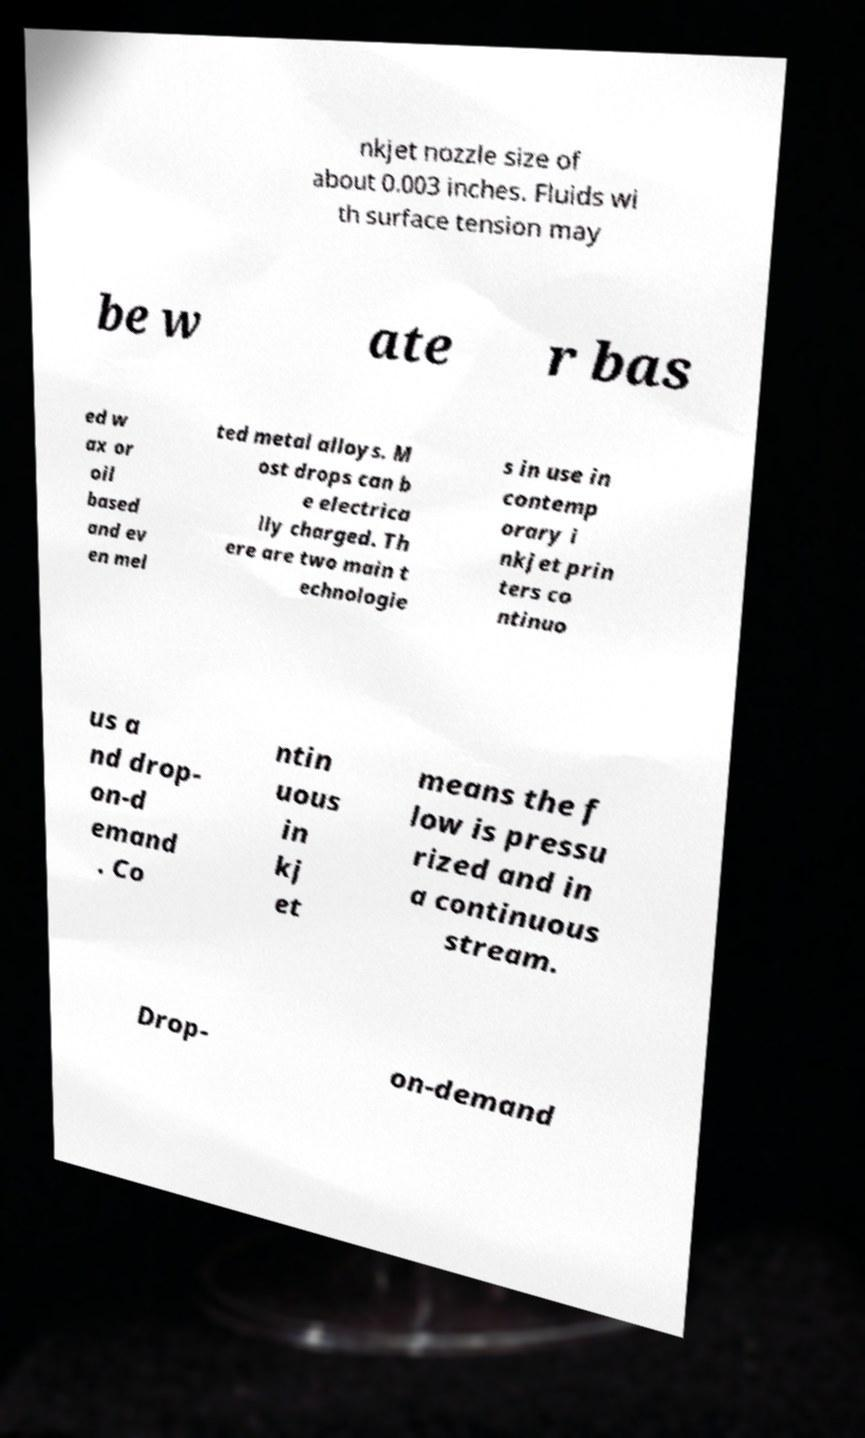I need the written content from this picture converted into text. Can you do that? nkjet nozzle size of about 0.003 inches. Fluids wi th surface tension may be w ate r bas ed w ax or oil based and ev en mel ted metal alloys. M ost drops can b e electrica lly charged. Th ere are two main t echnologie s in use in contemp orary i nkjet prin ters co ntinuo us a nd drop- on-d emand . Co ntin uous in kj et means the f low is pressu rized and in a continuous stream. Drop- on-demand 